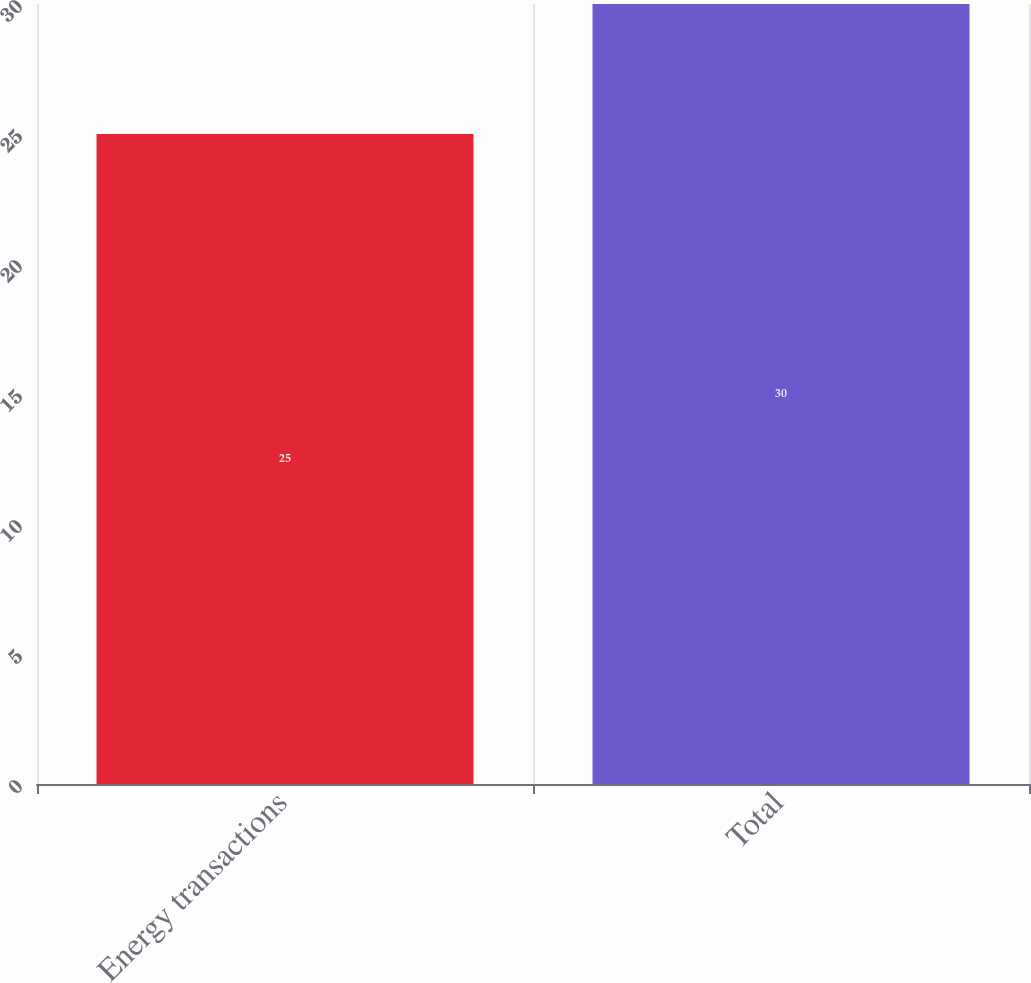Convert chart to OTSL. <chart><loc_0><loc_0><loc_500><loc_500><bar_chart><fcel>Energy transactions<fcel>Total<nl><fcel>25<fcel>30<nl></chart> 